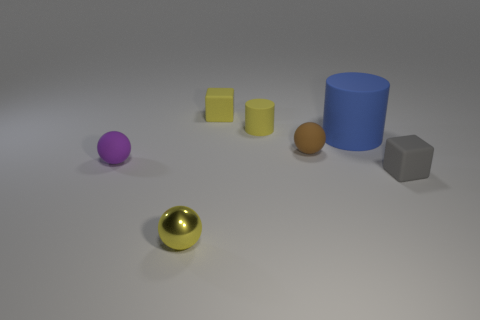Subtract all small yellow metal spheres. How many spheres are left? 2 Add 1 large blue objects. How many objects exist? 8 Subtract all gray cubes. How many cubes are left? 1 Subtract all blocks. How many objects are left? 5 Subtract all yellow matte blocks. Subtract all brown rubber things. How many objects are left? 5 Add 2 shiny spheres. How many shiny spheres are left? 3 Add 7 tiny brown rubber spheres. How many tiny brown rubber spheres exist? 8 Subtract 1 brown balls. How many objects are left? 6 Subtract 2 balls. How many balls are left? 1 Subtract all blue cylinders. Subtract all cyan cubes. How many cylinders are left? 1 